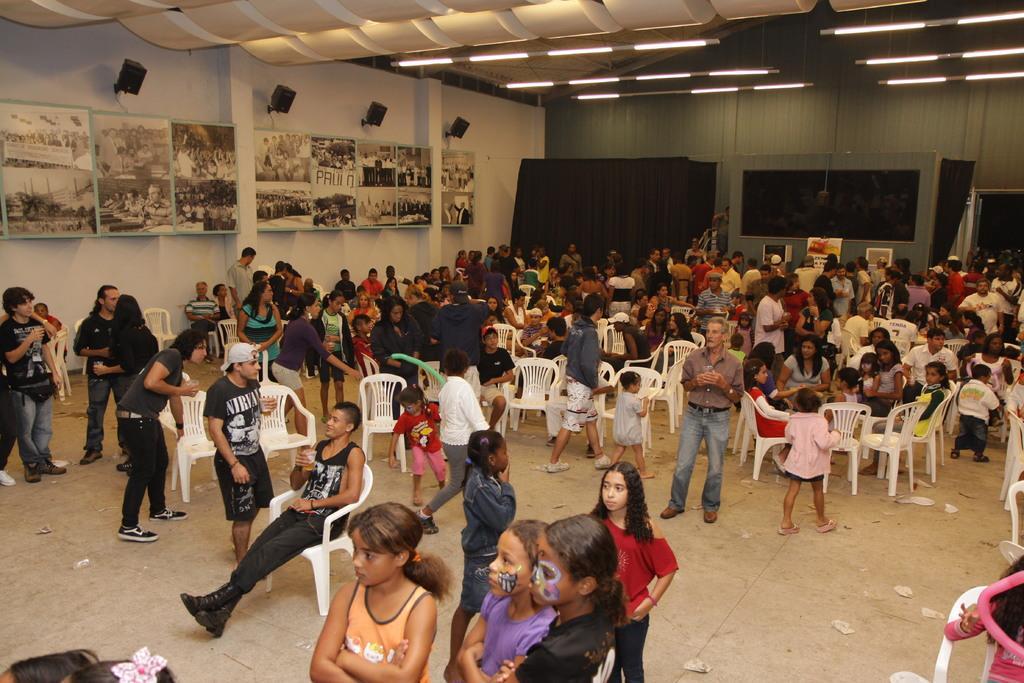Describe this image in one or two sentences. Here we can see group of people. Few people are sitting on the chairs. Here we can see boards, clothes, and lights. In the background we can see wall. 